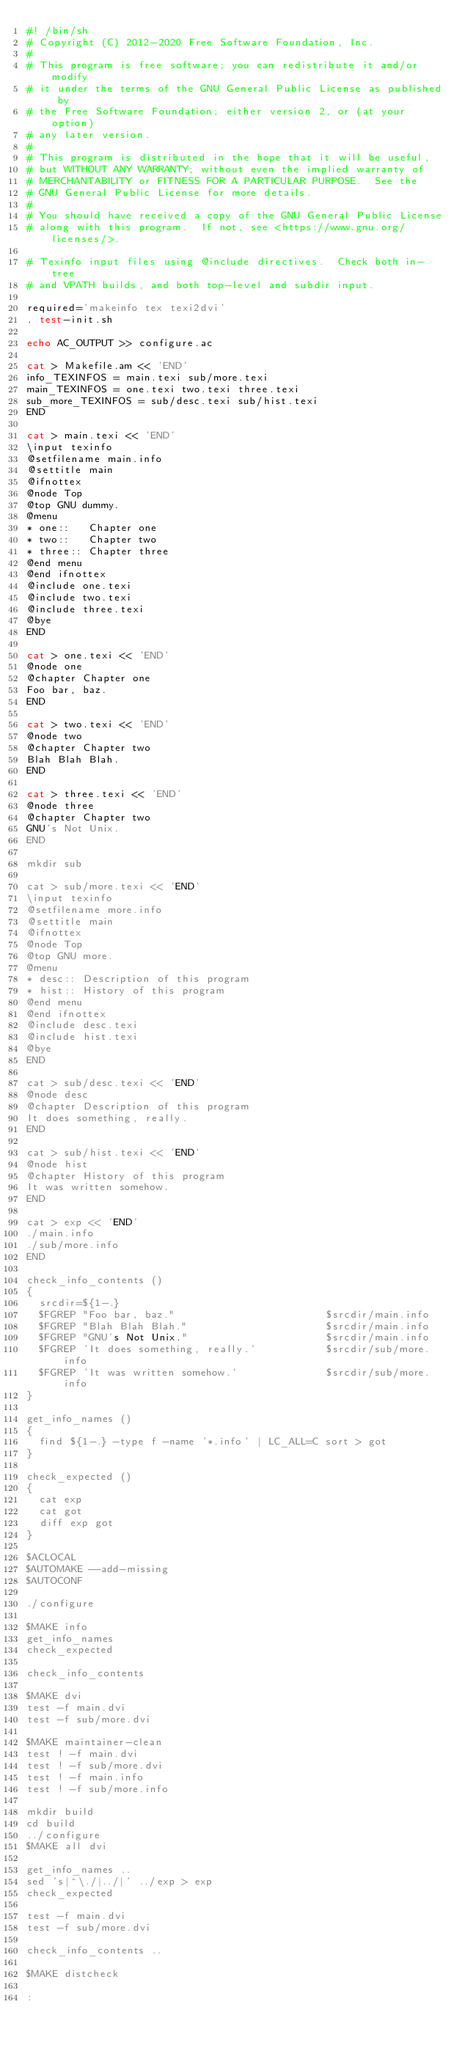Convert code to text. <code><loc_0><loc_0><loc_500><loc_500><_Bash_>#! /bin/sh
# Copyright (C) 2012-2020 Free Software Foundation, Inc.
#
# This program is free software; you can redistribute it and/or modify
# it under the terms of the GNU General Public License as published by
# the Free Software Foundation; either version 2, or (at your option)
# any later version.
#
# This program is distributed in the hope that it will be useful,
# but WITHOUT ANY WARRANTY; without even the implied warranty of
# MERCHANTABILITY or FITNESS FOR A PARTICULAR PURPOSE.  See the
# GNU General Public License for more details.
#
# You should have received a copy of the GNU General Public License
# along with this program.  If not, see <https://www.gnu.org/licenses/>.

# Texinfo input files using @include directives.  Check both in-tree
# and VPATH builds, and both top-level and subdir input.

required='makeinfo tex texi2dvi'
. test-init.sh

echo AC_OUTPUT >> configure.ac

cat > Makefile.am << 'END'
info_TEXINFOS = main.texi sub/more.texi
main_TEXINFOS = one.texi two.texi three.texi
sub_more_TEXINFOS = sub/desc.texi sub/hist.texi
END

cat > main.texi << 'END'
\input texinfo
@setfilename main.info
@settitle main
@ifnottex
@node Top
@top GNU dummy.
@menu
* one::   Chapter one
* two::   Chapter two
* three:: Chapter three
@end menu
@end ifnottex
@include one.texi
@include two.texi
@include three.texi
@bye
END

cat > one.texi << 'END'
@node one
@chapter Chapter one
Foo bar, baz.
END

cat > two.texi << 'END'
@node two
@chapter Chapter two
Blah Blah Blah.
END

cat > three.texi << 'END'
@node three
@chapter Chapter two
GNU's Not Unix.
END

mkdir sub

cat > sub/more.texi << 'END'
\input texinfo
@setfilename more.info
@settitle main
@ifnottex
@node Top
@top GNU more.
@menu
* desc:: Description of this program
* hist:: History of this program
@end menu
@end ifnottex
@include desc.texi
@include hist.texi
@bye
END

cat > sub/desc.texi << 'END'
@node desc
@chapter Description of this program
It does something, really.
END

cat > sub/hist.texi << 'END'
@node hist
@chapter History of this program
It was written somehow.
END

cat > exp << 'END'
./main.info
./sub/more.info
END

check_info_contents ()
{
  srcdir=${1-.}
  $FGREP "Foo bar, baz."                        $srcdir/main.info
  $FGREP "Blah Blah Blah."                      $srcdir/main.info
  $FGREP "GNU's Not Unix."                      $srcdir/main.info
  $FGREP 'It does something, really.'           $srcdir/sub/more.info
  $FGREP 'It was written somehow.'              $srcdir/sub/more.info
}

get_info_names ()
{
  find ${1-.} -type f -name '*.info' | LC_ALL=C sort > got
}

check_expected ()
{
  cat exp
  cat got
  diff exp got
}

$ACLOCAL
$AUTOMAKE --add-missing
$AUTOCONF

./configure

$MAKE info
get_info_names
check_expected

check_info_contents

$MAKE dvi
test -f main.dvi
test -f sub/more.dvi

$MAKE maintainer-clean
test ! -f main.dvi
test ! -f sub/more.dvi
test ! -f main.info
test ! -f sub/more.info

mkdir build
cd build
../configure
$MAKE all dvi

get_info_names ..
sed 's|^\./|../|' ../exp > exp
check_expected

test -f main.dvi
test -f sub/more.dvi

check_info_contents ..

$MAKE distcheck

:
</code> 